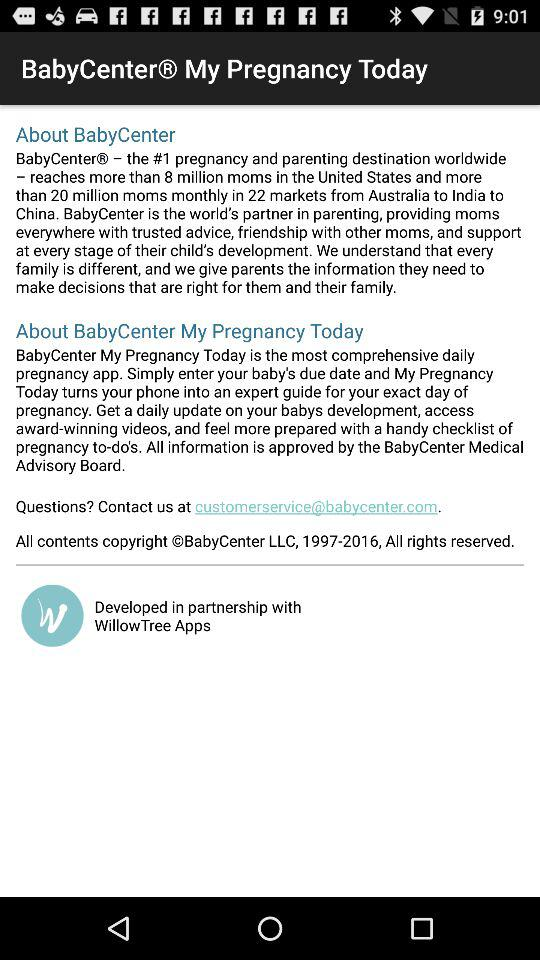What is the email address given to contact the application? The email address is customerservice@babycenter.com. 